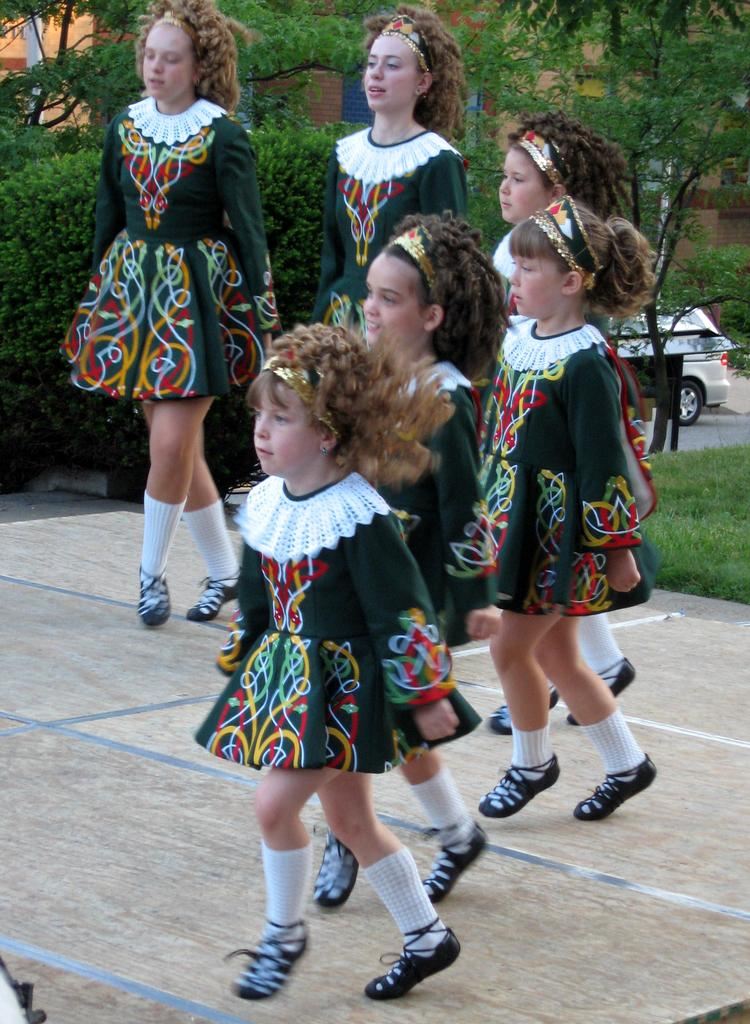What is happening in the image involving the girls? The girls appear to be dancing on the floor. What can be seen in the background of the image? There are buildings, trees, and a car visible on the road in the background of the image. What type of lock can be seen on the sun in the image? There is no lock or sun present in the image. 